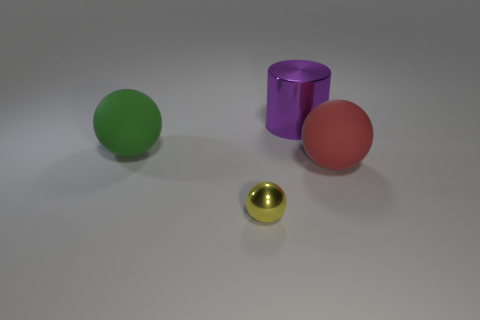Subtract all green cylinders. Subtract all blue balls. How many cylinders are left? 1 Add 3 small green objects. How many objects exist? 7 Subtract all balls. How many objects are left? 1 Add 2 green shiny objects. How many green shiny objects exist? 2 Subtract 1 green spheres. How many objects are left? 3 Subtract all purple shiny things. Subtract all yellow objects. How many objects are left? 2 Add 3 big metal cylinders. How many big metal cylinders are left? 4 